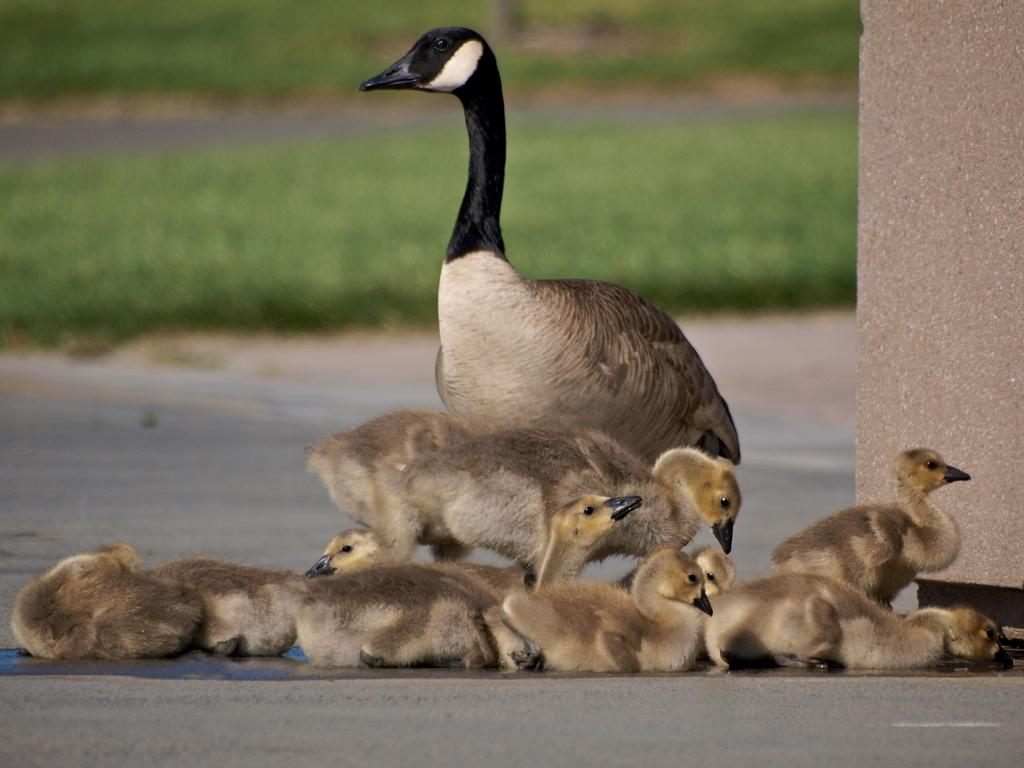What type of animal is the main subject in the image? There is a duck in the image. Are there any other animals present in the image? Yes, there are ducklings in the image. What color is the background of the image? The background of the image is green. How is the background of the image depicted? The background is blurred. What type of camp can be seen in the background of the image? There is no camp present in the image; the background is green and blurred. 